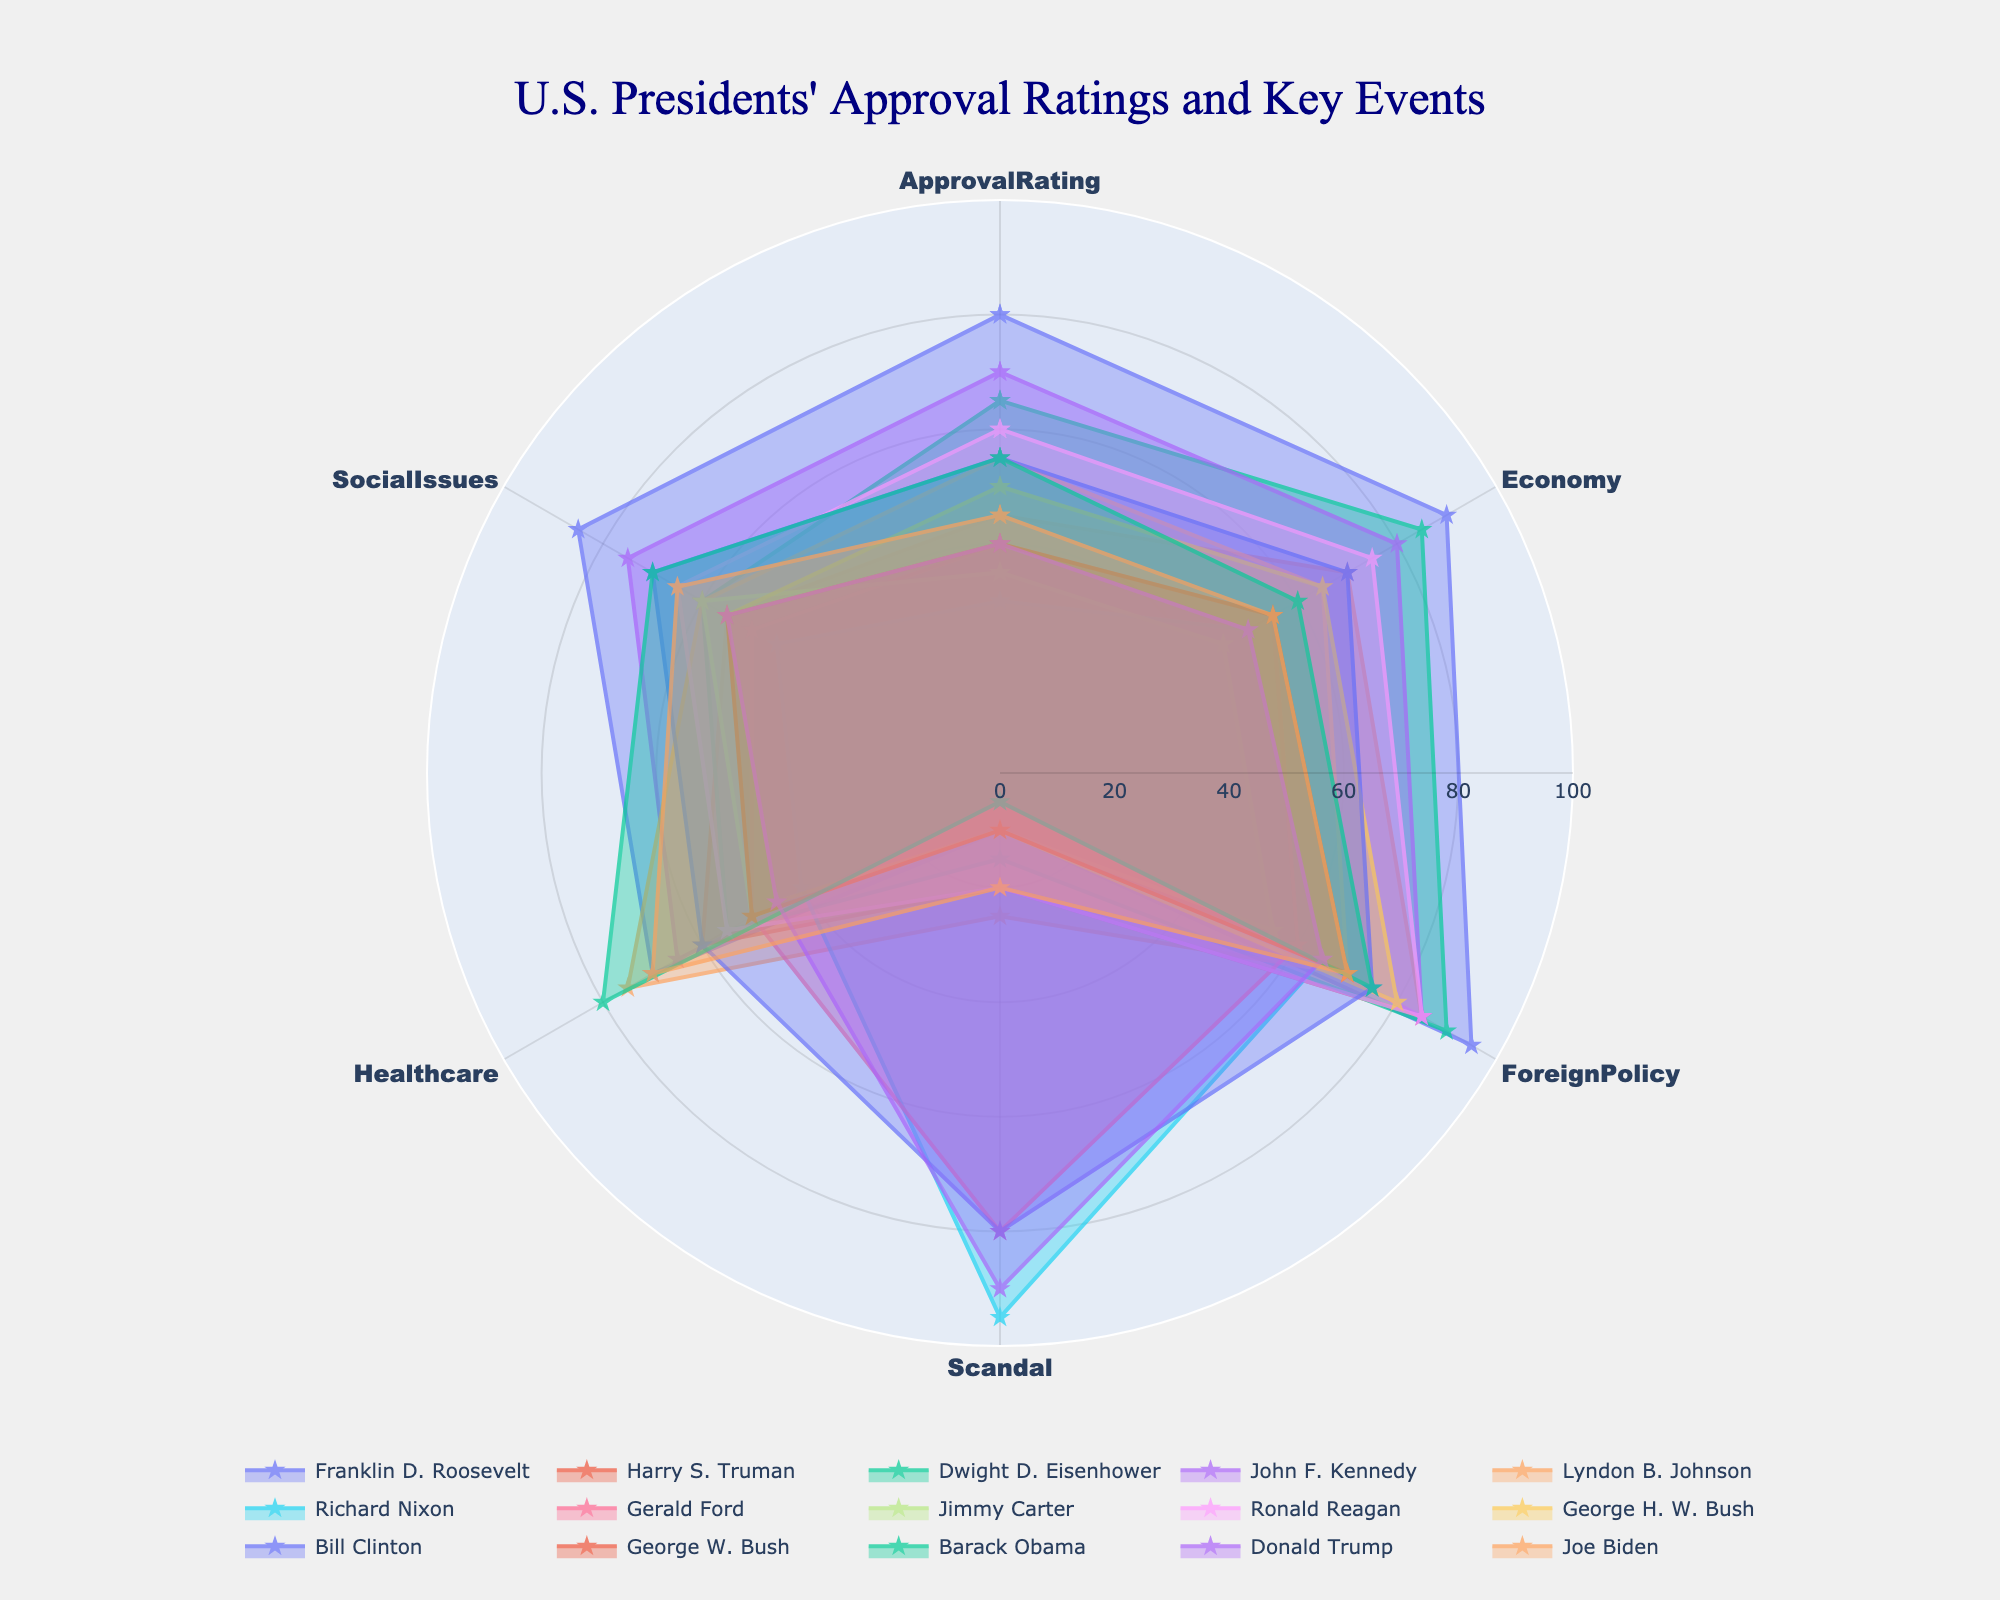Which president has the highest approval rating? From the radar chart, look for the point that extends furthest on the 'ApprovalRating' axis. Franklin D. Roosevelt has the highest approval rating at 80.
Answer: Franklin D. Roosevelt Which two presidents have the closest approval ratings? Compare all the approval ratings on the chart to find the smallest difference between ratings. Barack Obama and Bill Clinton both have approval ratings of 55.
Answer: Barack Obama and Bill Clinton What's the average approval rating of all presidents? Sum up all the approval ratings and divide by the number of presidents (15). The sum is 800, and the average is 800/15.
Answer: 53.33 How many presidents have an approval rating above 50? Count the number of presidents whose radar chart extends beyond 50 on the 'ApprovalRating' axis. Six presidents have approval ratings above 50.
Answer: Six Which president has the highest score in the 'Scandal' category? Identify which president's data point extends the furthest in the 'Scandal' axis. Richard Nixon has the highest score in 'Scandal' with 95.
Answer: Richard Nixon Is there a president with higher scores in both 'Economy' and 'ForeignPolicy' than in 'ApprovalRating'? Compare the values of 'Economy', 'ForeignPolicy', and 'ApprovalRating' axes for each president. Both Dwight D. Eisenhower and Ronald Reagan have higher scores in 'Economy' and 'ForeignPolicy' than in 'ApprovalRating'.
Answer: Dwight D. Eisenhower and Ronald Reagan Which president has the lowest score in 'Scandal'? Find the president whose data point extends the least in the 'Scandal' axis. John F. Kennedy and Barack Obama both score 5 in 'Scandal'.
Answer: John F. Kennedy and Barack Obama What is the total score for 'Healthcare' among all presidents? Sum up the 'Healthcare' scores of all presidents. The total is 70 + 60 + 55 + 65 + 75 + 40 + 50 + 50 + 55 + 45 + 60 + 50 + 80 + 45 + 70.
Answer: 870 Which category do most presidents score the lowest? Compare the data points' extents in each category across presidents to find the category with the most axes near the center. 'Scandal' is the category where most presidents score the lowest.
Answer: Scandal 